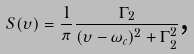Convert formula to latex. <formula><loc_0><loc_0><loc_500><loc_500>S ( \upsilon ) = \frac { 1 } { \pi } \frac { \Gamma _ { 2 } } { ( \upsilon - \omega _ { c } ) ^ { 2 } + \Gamma _ { 2 } ^ { 2 } } \text {,}</formula> 